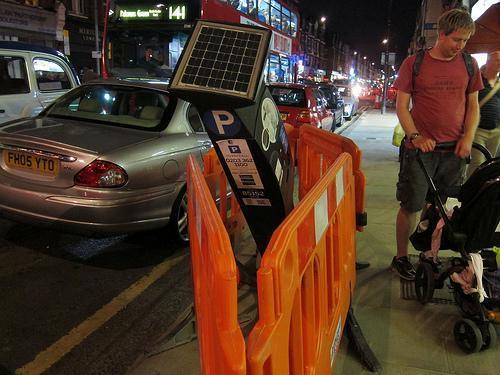How many people?
Give a very brief answer. 2. 